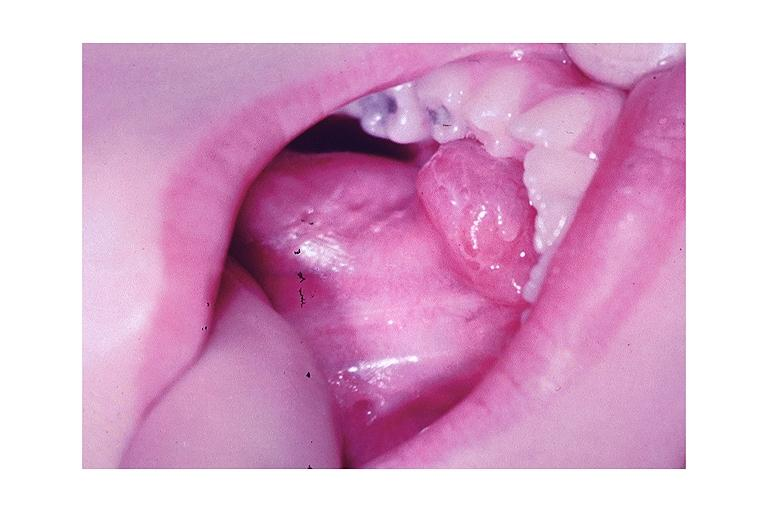where is this?
Answer the question using a single word or phrase. Oral 